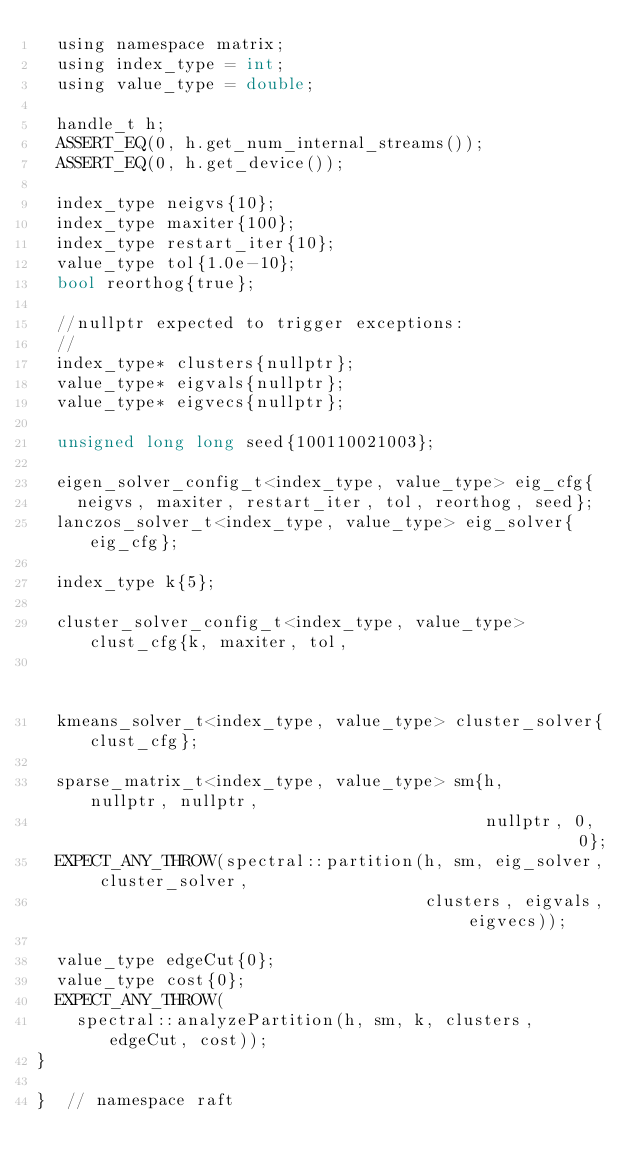<code> <loc_0><loc_0><loc_500><loc_500><_Cuda_>  using namespace matrix;
  using index_type = int;
  using value_type = double;

  handle_t h;
  ASSERT_EQ(0, h.get_num_internal_streams());
  ASSERT_EQ(0, h.get_device());

  index_type neigvs{10};
  index_type maxiter{100};
  index_type restart_iter{10};
  value_type tol{1.0e-10};
  bool reorthog{true};

  //nullptr expected to trigger exceptions:
  //
  index_type* clusters{nullptr};
  value_type* eigvals{nullptr};
  value_type* eigvecs{nullptr};

  unsigned long long seed{100110021003};

  eigen_solver_config_t<index_type, value_type> eig_cfg{
    neigvs, maxiter, restart_iter, tol, reorthog, seed};
  lanczos_solver_t<index_type, value_type> eig_solver{eig_cfg};

  index_type k{5};

  cluster_solver_config_t<index_type, value_type> clust_cfg{k, maxiter, tol,
                                                            seed};
  kmeans_solver_t<index_type, value_type> cluster_solver{clust_cfg};

  sparse_matrix_t<index_type, value_type> sm{h,       nullptr, nullptr,
                                             nullptr, 0,       0};
  EXPECT_ANY_THROW(spectral::partition(h, sm, eig_solver, cluster_solver,
                                       clusters, eigvals, eigvecs));

  value_type edgeCut{0};
  value_type cost{0};
  EXPECT_ANY_THROW(
    spectral::analyzePartition(h, sm, k, clusters, edgeCut, cost));
}

}  // namespace raft
</code> 